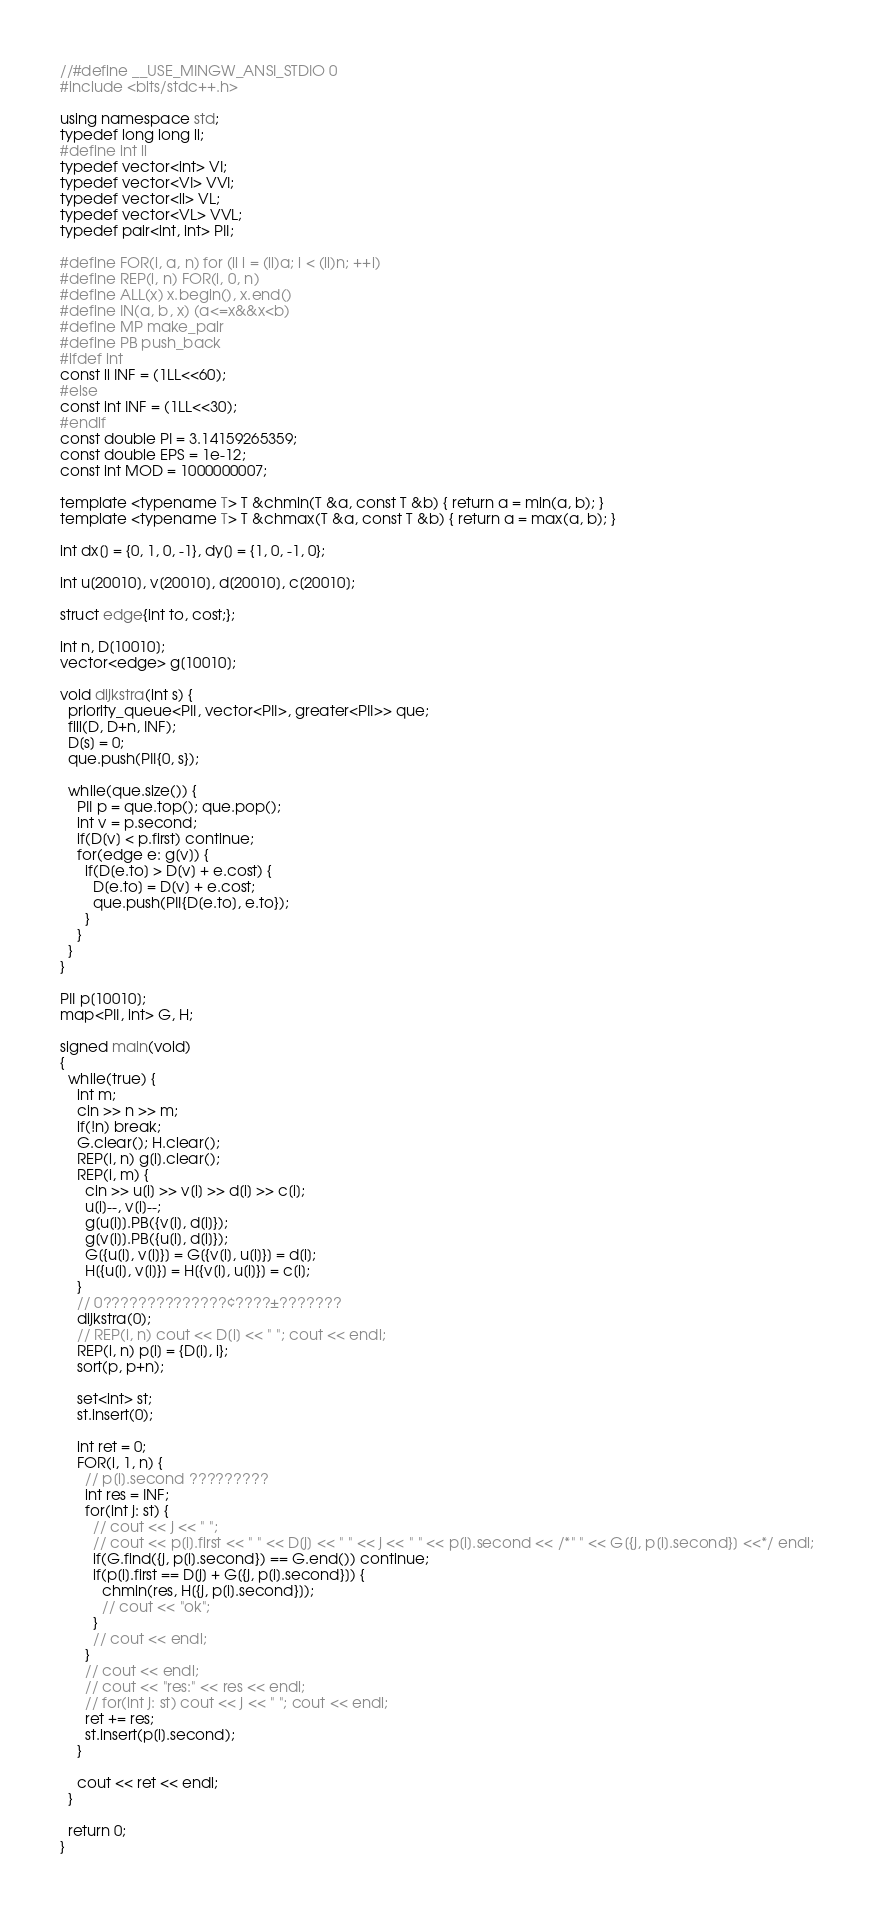Convert code to text. <code><loc_0><loc_0><loc_500><loc_500><_C++_>//#define __USE_MINGW_ANSI_STDIO 0
#include <bits/stdc++.h>

using namespace std;
typedef long long ll;
#define int ll
typedef vector<int> VI;
typedef vector<VI> VVI;
typedef vector<ll> VL;
typedef vector<VL> VVL;
typedef pair<int, int> PII;

#define FOR(i, a, n) for (ll i = (ll)a; i < (ll)n; ++i)
#define REP(i, n) FOR(i, 0, n)
#define ALL(x) x.begin(), x.end()
#define IN(a, b, x) (a<=x&&x<b)
#define MP make_pair
#define PB push_back
#ifdef int
const ll INF = (1LL<<60);
#else
const int INF = (1LL<<30);
#endif
const double PI = 3.14159265359;
const double EPS = 1e-12;
const int MOD = 1000000007;

template <typename T> T &chmin(T &a, const T &b) { return a = min(a, b); }
template <typename T> T &chmax(T &a, const T &b) { return a = max(a, b); }

int dx[] = {0, 1, 0, -1}, dy[] = {1, 0, -1, 0};

int u[20010], v[20010], d[20010], c[20010];

struct edge{int to, cost;};

int n, D[10010];
vector<edge> g[10010];

void dijkstra(int s) {
  priority_queue<PII, vector<PII>, greater<PII>> que;
  fill(D, D+n, INF);
  D[s] = 0;
  que.push(PII{0, s});

  while(que.size()) {
    PII p = que.top(); que.pop();
    int v = p.second;
    if(D[v] < p.first) continue;
    for(edge e: g[v]) {
      if(D[e.to] > D[v] + e.cost) {
        D[e.to] = D[v] + e.cost;
        que.push(PII{D[e.to], e.to});
      }
    }
  }
}

PII p[10010];
map<PII, int> G, H;

signed main(void)
{
  while(true) {
    int m;
    cin >> n >> m;
    if(!n) break;
    G.clear(); H.clear();
    REP(i, n) g[i].clear();
    REP(i, m) {
      cin >> u[i] >> v[i] >> d[i] >> c[i];
      u[i]--, v[i]--;
      g[u[i]].PB({v[i], d[i]});
      g[v[i]].PB({u[i], d[i]});
      G[{u[i], v[i]}] = G[{v[i], u[i]}] = d[i];
      H[{u[i], v[i]}] = H[{v[i], u[i]}] = c[i];
    }
    // 0??????????????¢????±???????
    dijkstra(0);
    // REP(i, n) cout << D[i] << " "; cout << endl;
    REP(i, n) p[i] = {D[i], i};
    sort(p, p+n);

    set<int> st;
    st.insert(0);

    int ret = 0;
    FOR(i, 1, n) {
      // p[i].second ?????????
      int res = INF;
      for(int j: st) {
        // cout << j << " ";
        // cout << p[i].first << " " << D[j] << " " << j << " " << p[i].second << /*" " << G[{j, p[i].second}] <<*/ endl;
        if(G.find({j, p[i].second}) == G.end()) continue;
        if(p[i].first == D[j] + G[{j, p[i].second}]) {
          chmin(res, H[{j, p[i].second}]);
          // cout << "ok";
        }
        // cout << endl;
      }
      // cout << endl;
      // cout << "res:" << res << endl;
      // for(int j: st) cout << j << " "; cout << endl;
      ret += res;
      st.insert(p[i].second);
    }

    cout << ret << endl;
  }

  return 0;
}</code> 